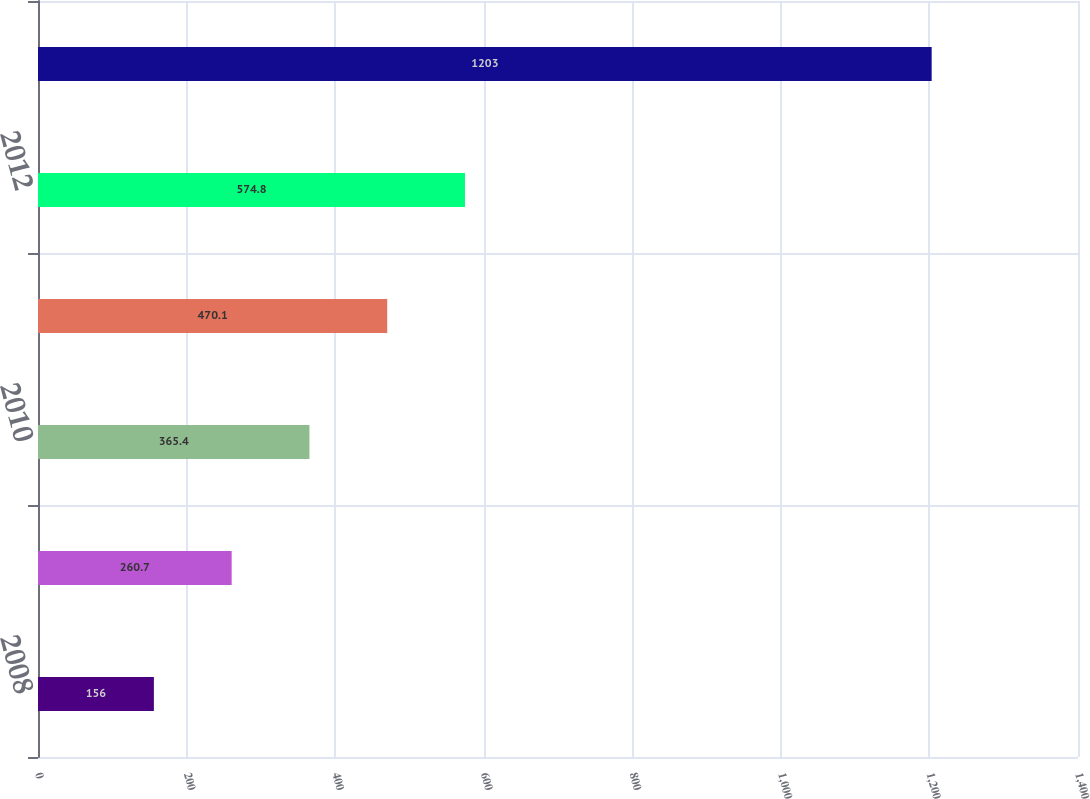Convert chart to OTSL. <chart><loc_0><loc_0><loc_500><loc_500><bar_chart><fcel>2008<fcel>2009<fcel>2010<fcel>2011<fcel>2012<fcel>2013-2017<nl><fcel>156<fcel>260.7<fcel>365.4<fcel>470.1<fcel>574.8<fcel>1203<nl></chart> 